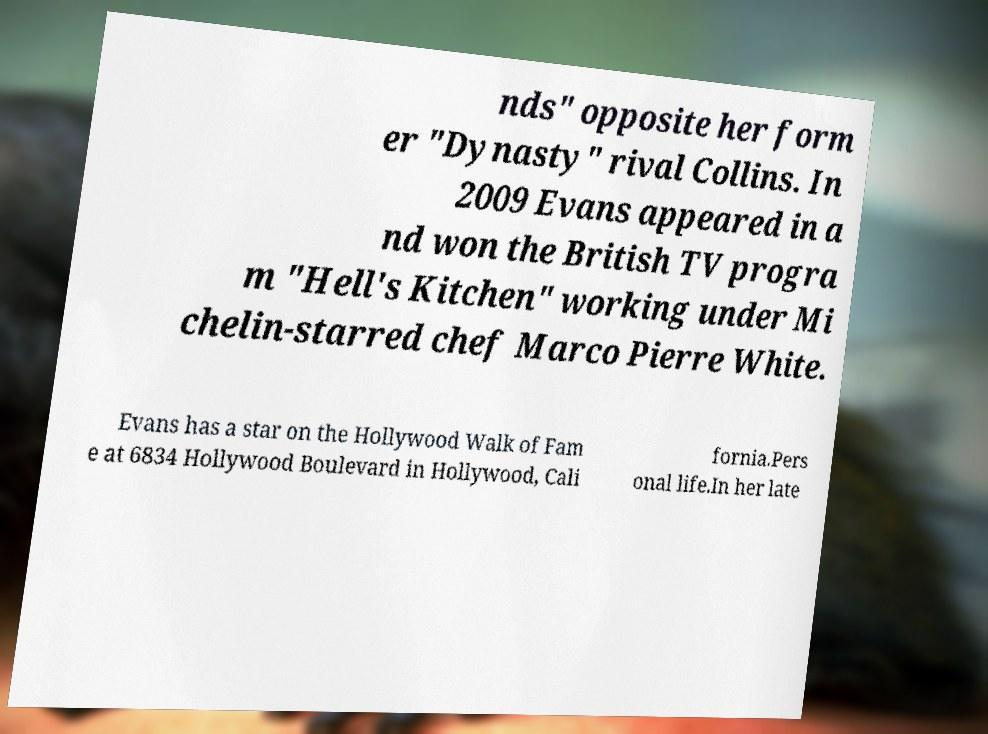I need the written content from this picture converted into text. Can you do that? nds" opposite her form er "Dynasty" rival Collins. In 2009 Evans appeared in a nd won the British TV progra m "Hell's Kitchen" working under Mi chelin-starred chef Marco Pierre White. Evans has a star on the Hollywood Walk of Fam e at 6834 Hollywood Boulevard in Hollywood, Cali fornia.Pers onal life.In her late 